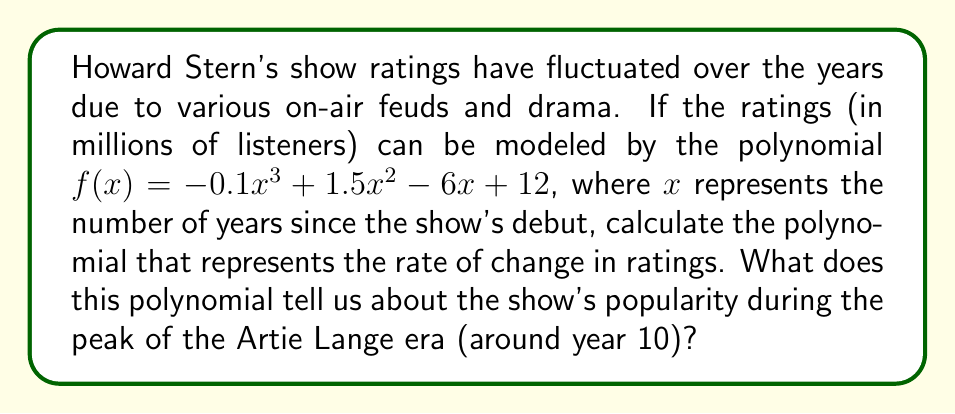Give your solution to this math problem. To find the rate of change in ratings, we need to calculate the derivative of the given polynomial $f(x)$.

Step 1: Differentiate $f(x) = -0.1x^3 + 1.5x^2 - 6x + 12$
$$f'(x) = (-0.1x^3)' + (1.5x^2)' + (-6x)' + (12)'$$
$$f'(x) = -0.3x^2 + 3x - 6$$

Step 2: This new polynomial $f'(x)$ represents the rate of change in ratings at any given time $x$.

Step 3: To analyze the show's popularity during the Artie Lange era (around year 10), we evaluate $f'(10)$:
$$f'(10) = -0.3(10)^2 + 3(10) - 6$$
$$f'(10) = -30 + 30 - 6 = -6$$

The negative value indicates that the ratings were decreasing at year 10, with a rate of 6 million listeners per year.

Step 4: To find the acceleration of the ratings change, we can calculate the second derivative:
$$f''(x) = (-0.3x^2 + 3x - 6)'$$
$$f''(x) = -0.6x + 3$$

At $x = 10$: $f''(10) = -0.6(10) + 3 = -3$

The negative second derivative confirms that the rate of ratings decline was increasing, indicating a potential downturn in the show's popularity during this period.
Answer: $f'(x) = -0.3x^2 + 3x - 6$; ratings decreasing at 6 million listeners per year at year 10. 